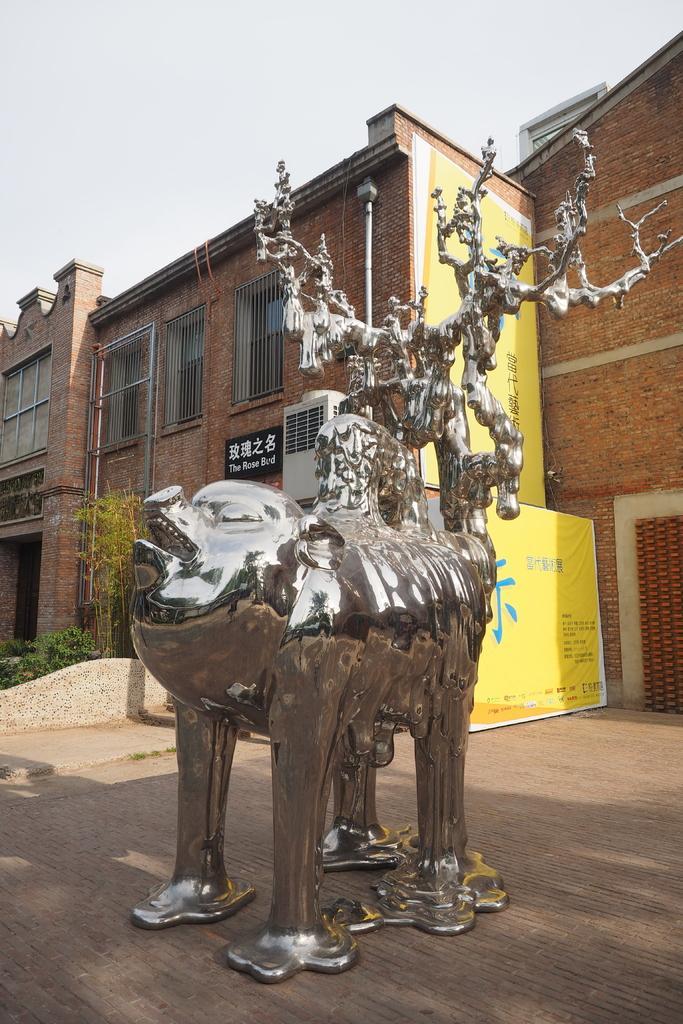Can you describe this image briefly? In this image I can see a building out side view and There is a statue visible in front of a building and there is a sky visible and there are some plants visible on the left side ,on the building there is a hoarding board ,on the hoarding board there is a some text written on that. 